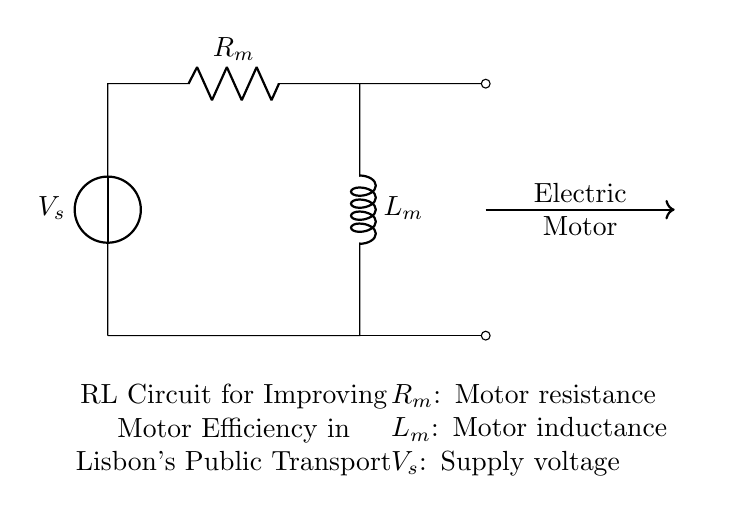What is the supply voltage in this circuit? The supply voltage, denoted as \( V_s \), is the voltage source connected at the top of the circuit diagram. The symbol indicates a source of voltage applied to the circuit components.
Answer: \( V_s \) What are the components connected in this RL circuit? The circuit consists of a voltage source, a resistor \( R_m \), and an inductor \( L_m \). These components are arranged to form the RL circuit used in electric motors for efficiency.
Answer: Voltage source, resistor, inductor What is the purpose of the inductor \( L_m \) in this circuit? The inductor \( L_m \) stores energy in a magnetic field when current flows through it, which helps in smoothing the current and improving the performance of the motor. This is crucial for enhancing operational efficiency.
Answer: Energy storage What is the relationship between resistance and motor efficiency in this circuit? Lower resistance in the motor reduces energy losses due to heat, leading to improved efficiency. The resistor \( R_m \) represents the motor's internal resistance which directly affects how much power is wasted.
Answer: Lower resistance, higher efficiency What happens to the current when the inductor \( L_m \) is introduced in the circuit? The inductor impedes changes in current, causing a delay in the rise and fall of current levels. This property allows for more stable and efficient current flow to the motor, enhancing overall performance.
Answer: Current stability What type of circuit is represented by this diagram? The circuit is classified as an RL circuit, which includes both a resistor and an inductor. Such circuits are essential in applications where inductance and resistance play a significant role in energy management.
Answer: RL circuit 